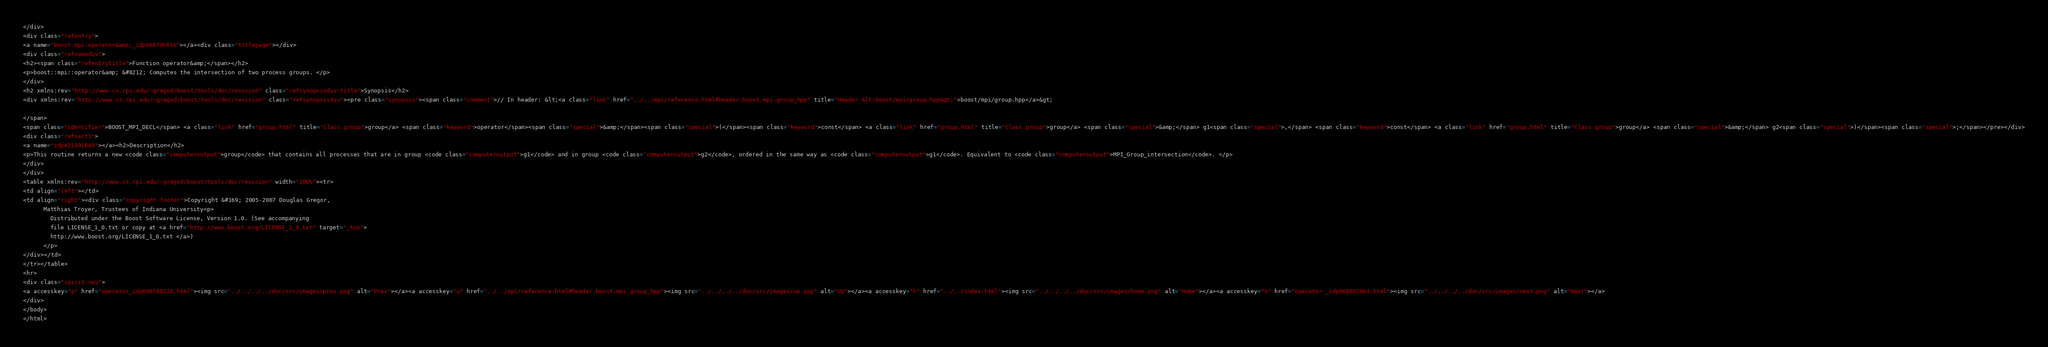<code> <loc_0><loc_0><loc_500><loc_500><_HTML_></div>
<div class="refentry">
<a name="boost.mpi.operator&amp;_idp668795616"></a><div class="titlepage"></div>
<div class="refnamediv">
<h2><span class="refentrytitle">Function operator&amp;</span></h2>
<p>boost::mpi::operator&amp; &#8212; Computes the intersection of two process groups. </p>
</div>
<h2 xmlns:rev="http://www.cs.rpi.edu/~gregod/boost/tools/doc/revision" class="refsynopsisdiv-title">Synopsis</h2>
<div xmlns:rev="http://www.cs.rpi.edu/~gregod/boost/tools/doc/revision" class="refsynopsisdiv"><pre class="synopsis"><span class="comment">// In header: &lt;<a class="link" href="../../mpi/reference.html#header.boost.mpi.group_hpp" title="Header &lt;boost/mpi/group.hpp&gt;">boost/mpi/group.hpp</a>&gt;

</span>
<span class="identifier">BOOST_MPI_DECL</span> <a class="link" href="group.html" title="Class group">group</a> <span class="keyword">operator</span><span class="special">&amp;</span><span class="special">(</span><span class="keyword">const</span> <a class="link" href="group.html" title="Class group">group</a> <span class="special">&amp;</span> g1<span class="special">,</span> <span class="keyword">const</span> <a class="link" href="group.html" title="Class group">group</a> <span class="special">&amp;</span> g2<span class="special">)</span><span class="special">;</span></pre></div>
<div class="refsect1">
<a name="idp421091840"></a><h2>Description</h2>
<p>This routine returns a new <code class="computeroutput">group</code> that contains all processes that are in group <code class="computeroutput">g1</code> and in group <code class="computeroutput">g2</code>, ordered in the same way as <code class="computeroutput">g1</code>. Equivalent to <code class="computeroutput">MPI_Group_intersection</code>. </p>
</div>
</div>
<table xmlns:rev="http://www.cs.rpi.edu/~gregod/boost/tools/doc/revision" width="100%"><tr>
<td align="left"></td>
<td align="right"><div class="copyright-footer">Copyright &#169; 2005-2007 Douglas Gregor,
      Matthias Troyer, Trustees of Indiana University<p>
        Distributed under the Boost Software License, Version 1.0. (See accompanying
        file LICENSE_1_0.txt or copy at <a href="http://www.boost.org/LICENSE_1_0.txt" target="_top">
        http://www.boost.org/LICENSE_1_0.txt </a>)
      </p>
</div></td>
</tr></table>
<hr>
<div class="spirit-nav">
<a accesskey="p" href="operator_idp668788224.html"><img src="../../../../doc/src/images/prev.png" alt="Prev"></a><a accesskey="u" href="../../mpi/reference.html#header.boost.mpi.group_hpp"><img src="../../../../doc/src/images/up.png" alt="Up"></a><a accesskey="h" href="../../index.html"><img src="../../../../doc/src/images/home.png" alt="Home"></a><a accesskey="n" href="operator-_idp668802064.html"><img src="../../../../doc/src/images/next.png" alt="Next"></a>
</div>
</body>
</html>
</code> 